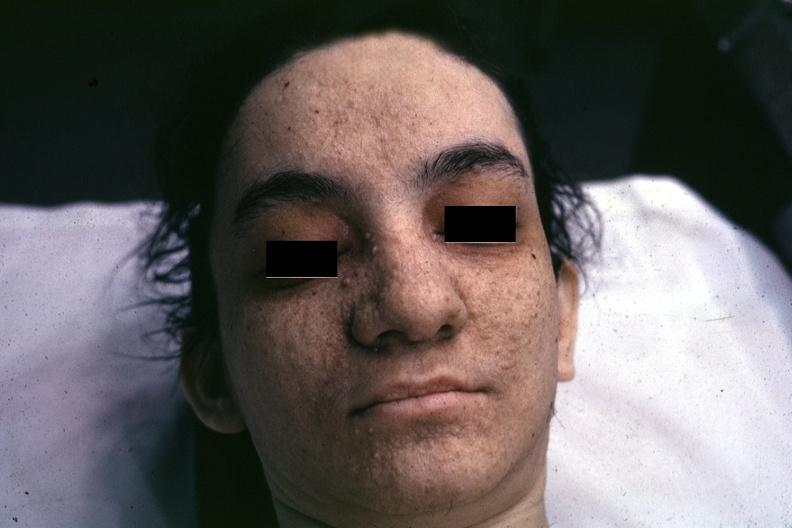what associated with tuberous sclerosis?
Answer the question using a single word or phrase. Very good example 